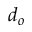<formula> <loc_0><loc_0><loc_500><loc_500>d _ { o }</formula> 